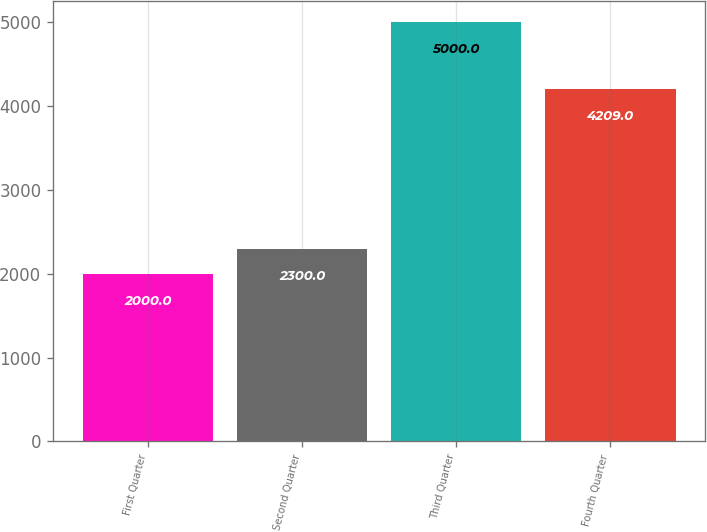Convert chart to OTSL. <chart><loc_0><loc_0><loc_500><loc_500><bar_chart><fcel>First Quarter<fcel>Second Quarter<fcel>Third Quarter<fcel>Fourth Quarter<nl><fcel>2000<fcel>2300<fcel>5000<fcel>4209<nl></chart> 